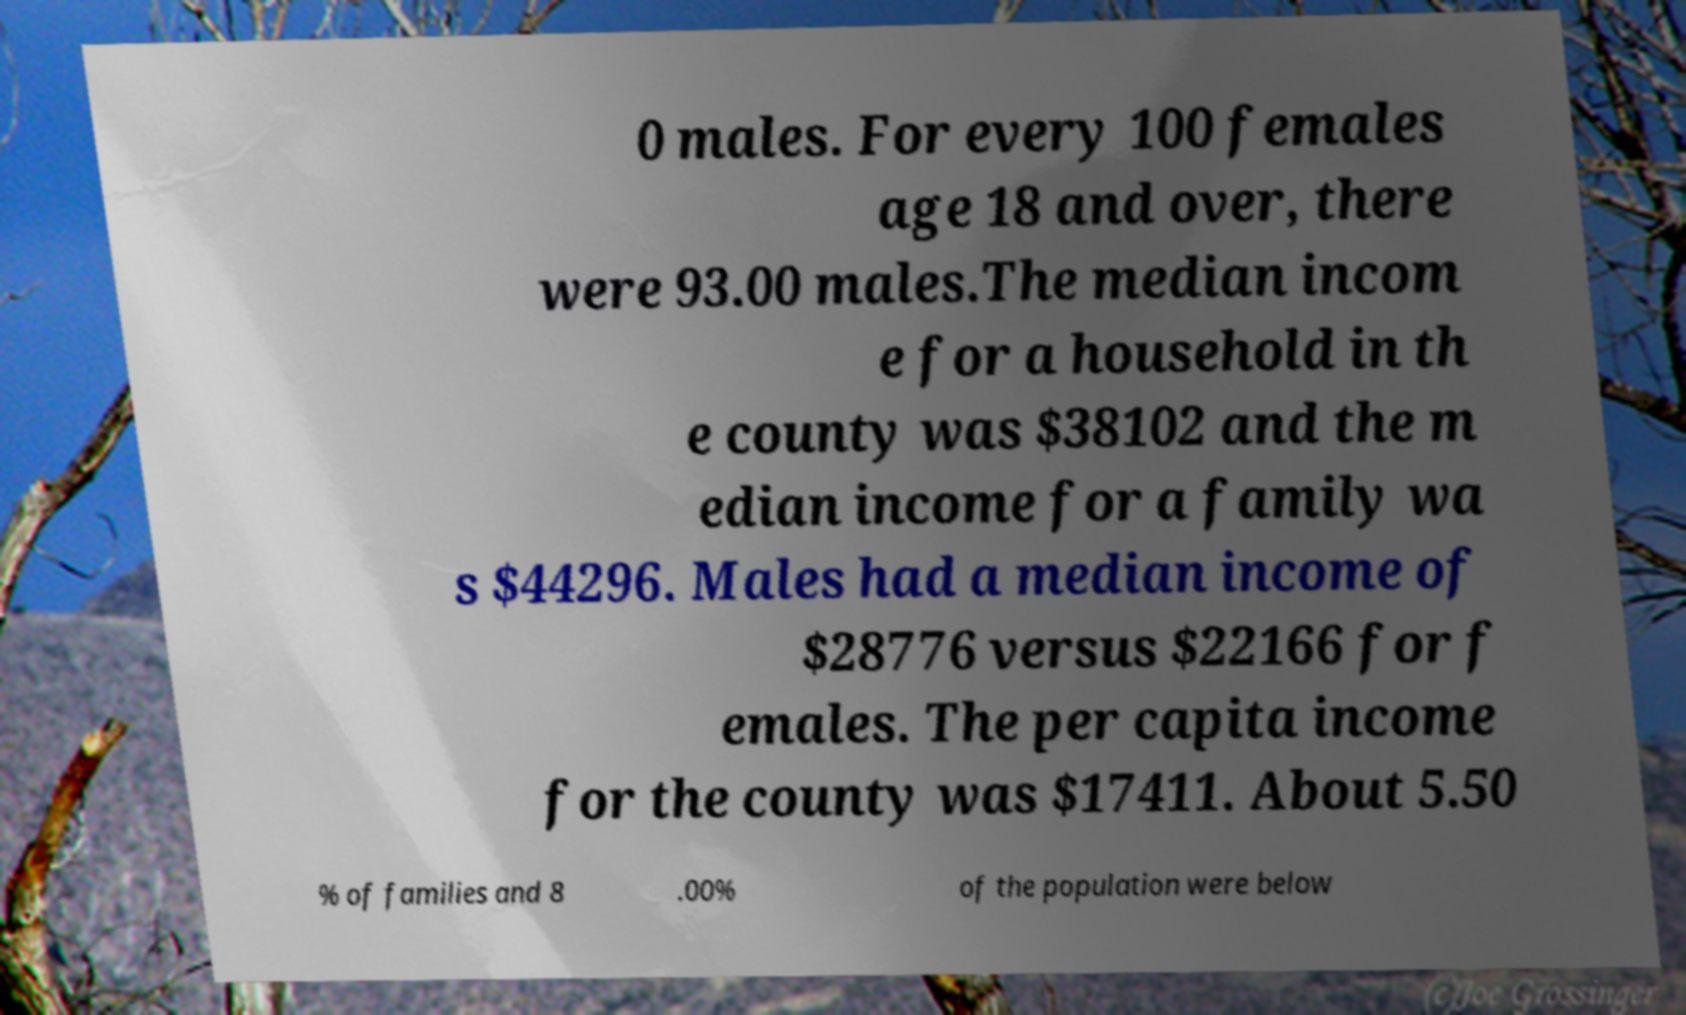Can you read and provide the text displayed in the image?This photo seems to have some interesting text. Can you extract and type it out for me? 0 males. For every 100 females age 18 and over, there were 93.00 males.The median incom e for a household in th e county was $38102 and the m edian income for a family wa s $44296. Males had a median income of $28776 versus $22166 for f emales. The per capita income for the county was $17411. About 5.50 % of families and 8 .00% of the population were below 